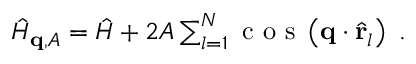Convert formula to latex. <formula><loc_0><loc_0><loc_500><loc_500>\begin{array} { r } { \hat { H } _ { q , A } = \hat { H } + 2 A \sum _ { l = 1 } ^ { N } \cos \left ( q \cdot \hat { r } _ { l } \right ) \ . } \end{array}</formula> 